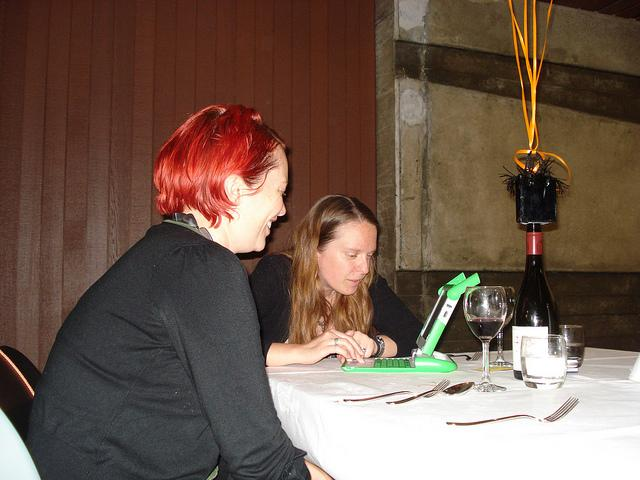Which process has been performed on the closer lady's hair?

Choices:
A) dying
B) braiding
C) perming
D) shaving completely dying 